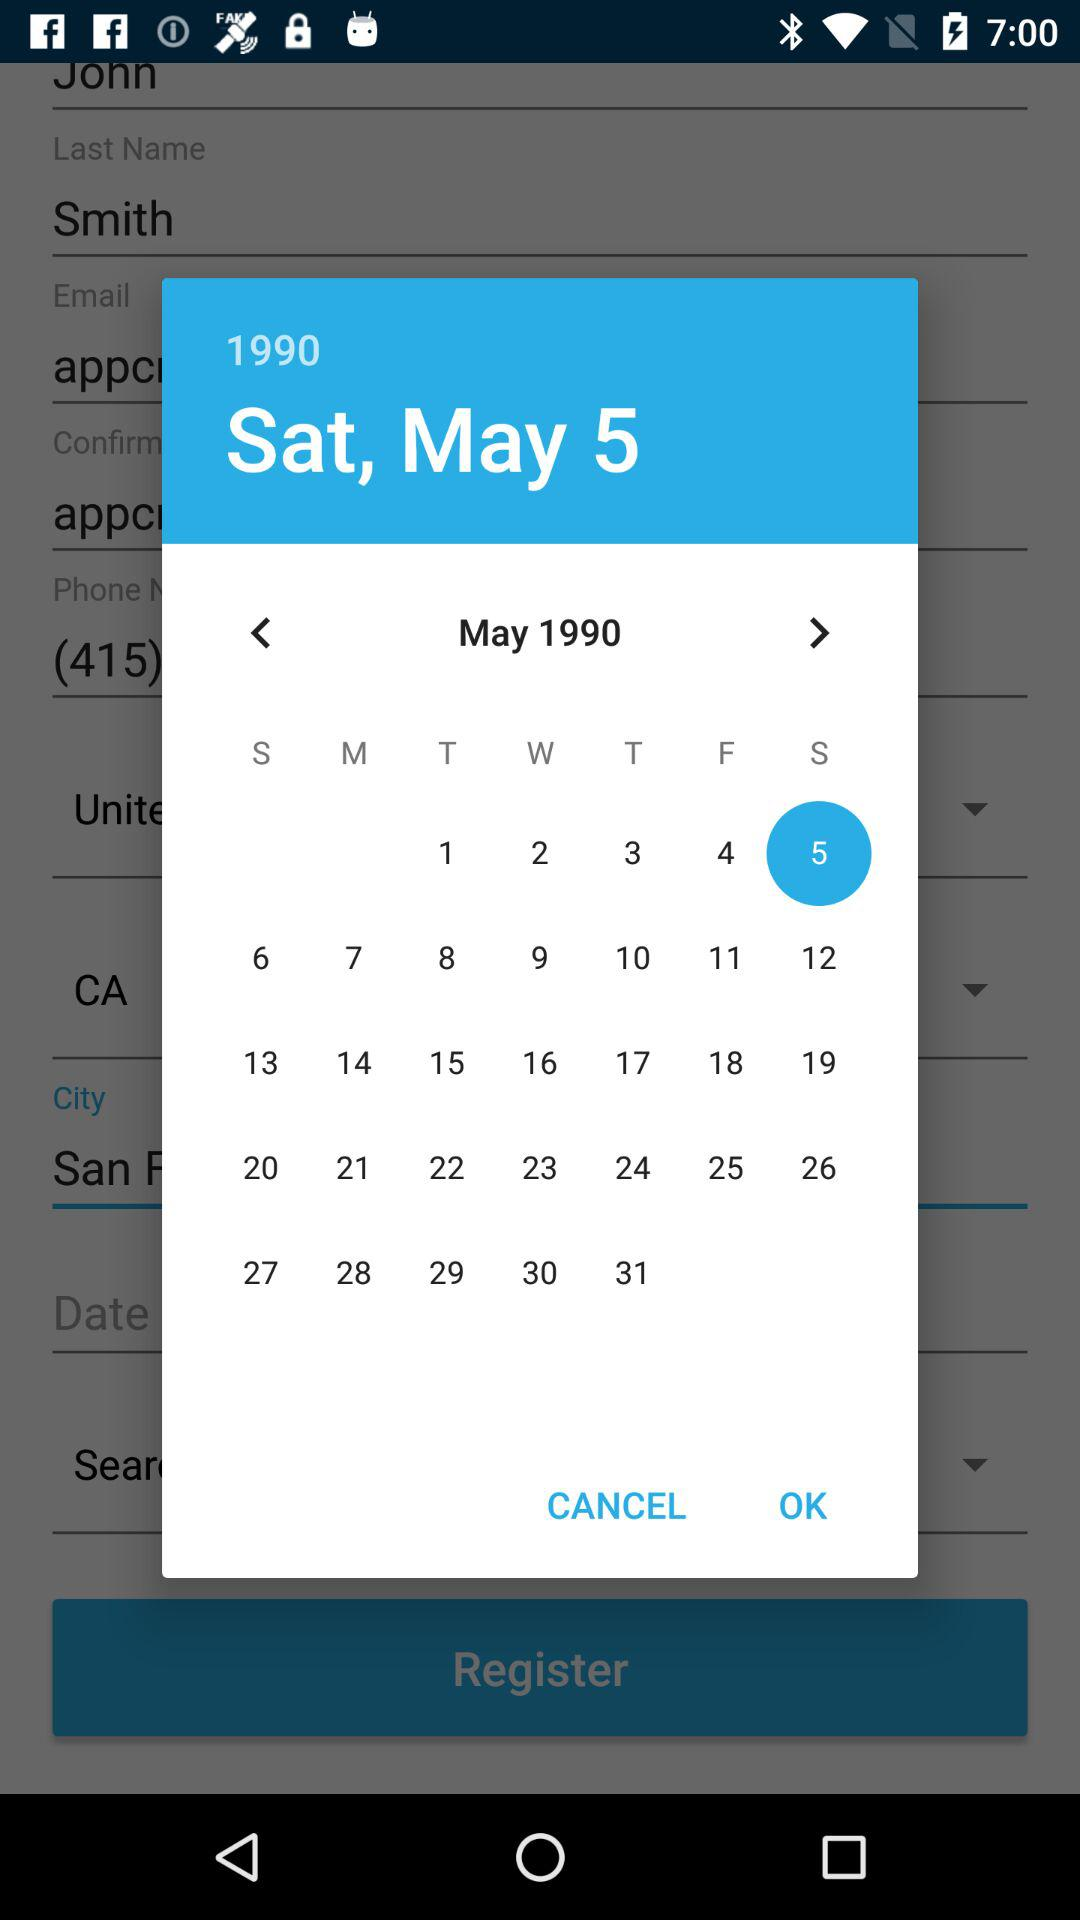Which day is it on May 1, 1990? The day is Tuesday. 